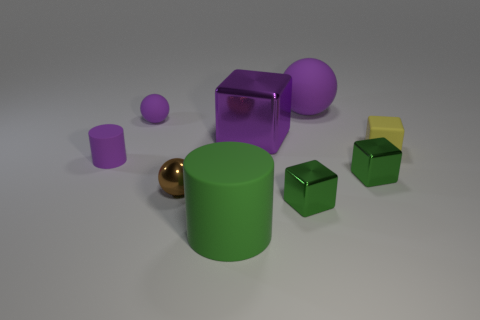What shapes and colors can we see in this image? The image features geometric shapes including cylinders, cubes, and spheres. The colors present are purple, green, yellow, and a reflective gold-like color.  Are there any patterns or consistencies in the arrangement of the shapes? The arrangement seems somewhat random, but you can notice that similar shapes are not directly next to one another, and there is a variety of sizes for each shape lending to a visually balanced composition. 